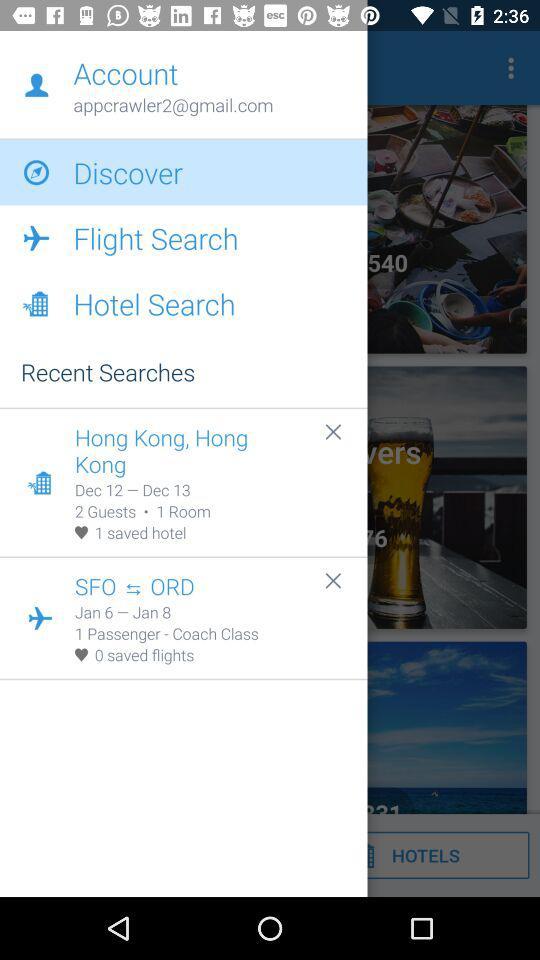What is the email address? The email address is appcrawler2@gmail.com. 